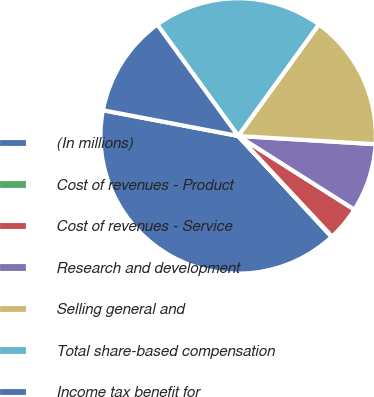<chart> <loc_0><loc_0><loc_500><loc_500><pie_chart><fcel>(In millions)<fcel>Cost of revenues - Product<fcel>Cost of revenues - Service<fcel>Research and development<fcel>Selling general and<fcel>Total share-based compensation<fcel>Income tax benefit for<nl><fcel>39.88%<fcel>0.07%<fcel>4.05%<fcel>8.03%<fcel>15.99%<fcel>19.97%<fcel>12.01%<nl></chart> 